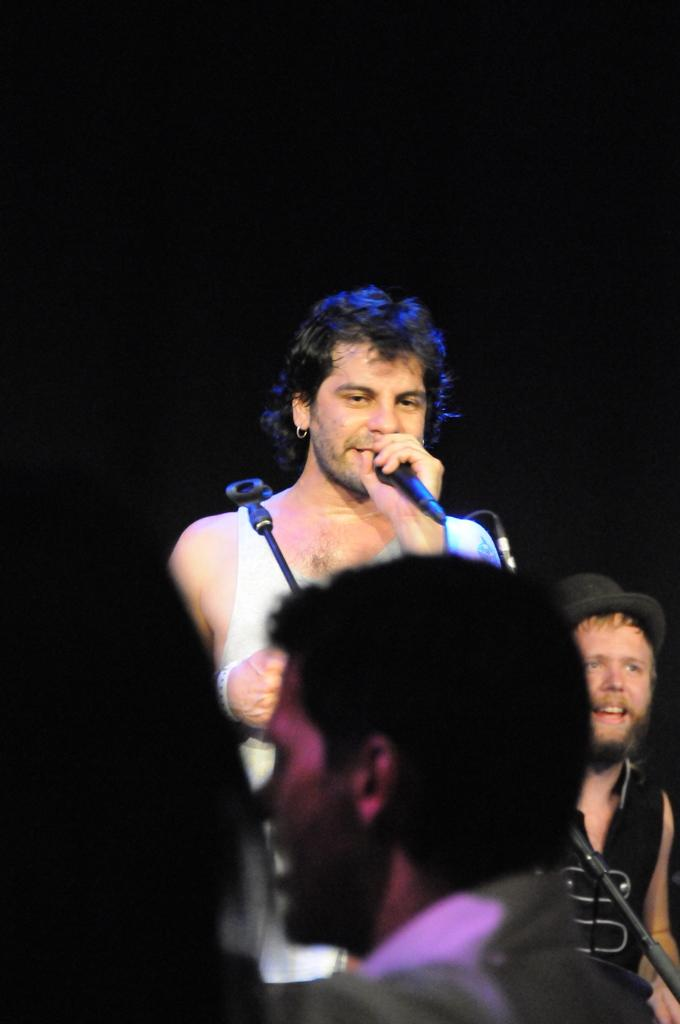What is the man in the image doing? The man is standing and singing into a microphone. Can you describe the people in the background of the image? There is a person smiling and a group of people in the background of the image. How many tomatoes are on the stage in the image? There are no tomatoes present in the image. What is the man doing with his hands while singing? The provided facts do not mention the man's hands, so we cannot determine what he is doing with them. 